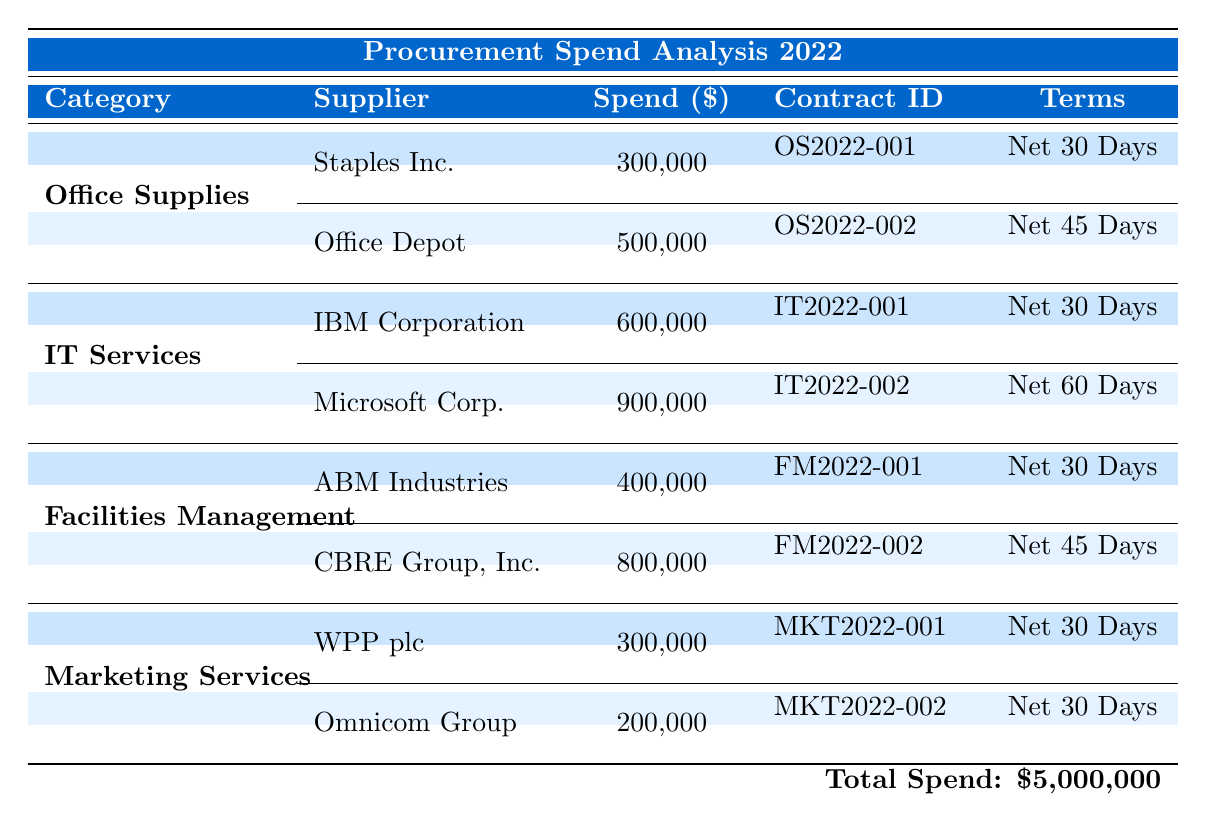What is the total spend on IT Services? The total spend on IT Services can be found in the table under the category "IT Services," where it states that the total category spend is 1,500,000.
Answer: 1,500,000 Which supplier had the highest spend in 2022? By looking at the spends listed for each supplier in the table, Microsoft Corp. has the highest spend at 900,000.
Answer: Microsoft Corp Are there any suppliers with contracts that have a net payment term of 30 days? Review the terms for each contract listed in the table. Staples Inc., IBM Corporation, WPP plc, and ABM Industries all have contracts with a net payment term of 30 days.
Answer: Yes How much did CBRE Group, Inc. spend compared to Staples Inc.? The spend for CBRE Group, Inc. is 800,000, while Staples Inc. spent 300,000. The difference can be calculated as 800,000 - 300,000 = 500,000.
Answer: 500,000 What percentage of total spend does Office Depot represent? To find the percentage, take Office Depot's spend of 500,000, divide it by the total spend of 5,000,000, and multiply by 100. (500,000 / 5,000,000) * 100 = 10%.
Answer: 10% How many suppliers are listed in the Marketing Services category? In the Marketing Services category, there are two suppliers listed: WPP plc and Omnicom Group. Therefore, the total number of suppliers is 2.
Answer: 2 Is there a supplier that has a contract ending in 2023? Review the end dates of the contracts provided in the table. Office Depot, Microsoft Corp., ABM Industries, and WPP plc all have contracts that end in 2023.
Answer: Yes Which category has the lowest total spend? Looking at the total category spend in the table, Marketing Services has the lowest total spend at 500,000 compared to the other categories.
Answer: Marketing Services How much did suppliers in the Facilities Management category spend in total? To calculate the total spend for Facilities Management, add the spends of ABM Industries (400,000) and CBRE Group, Inc. (800,000), which equals 1,200,000.
Answer: 1,200,000 